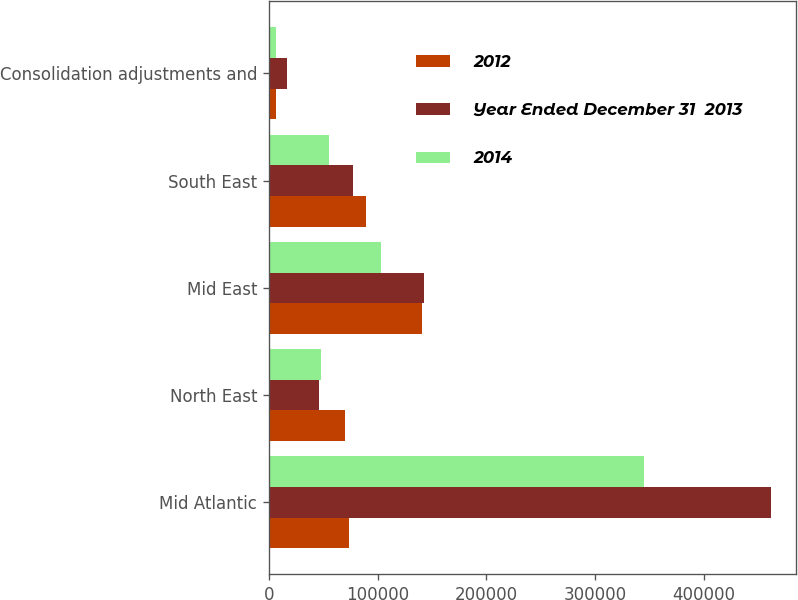Convert chart to OTSL. <chart><loc_0><loc_0><loc_500><loc_500><stacked_bar_chart><ecel><fcel>Mid Atlantic<fcel>North East<fcel>Mid East<fcel>South East<fcel>Consolidation adjustments and<nl><fcel>2012<fcel>73869.5<fcel>70462<fcel>141146<fcel>89544<fcel>6149<nl><fcel>Year Ended December 31  2013<fcel>461481<fcel>45860<fcel>142331<fcel>77277<fcel>16672<nl><fcel>2014<fcel>345009<fcel>48329<fcel>103128<fcel>55788<fcel>6649<nl></chart> 